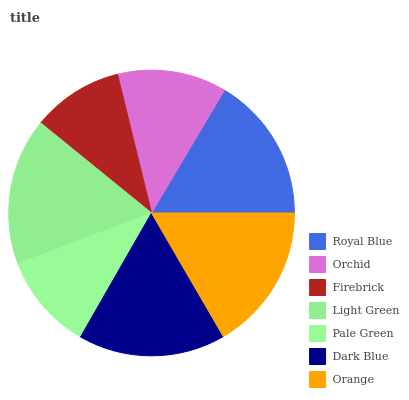Is Firebrick the minimum?
Answer yes or no. Yes. Is Dark Blue the maximum?
Answer yes or no. Yes. Is Orchid the minimum?
Answer yes or no. No. Is Orchid the maximum?
Answer yes or no. No. Is Royal Blue greater than Orchid?
Answer yes or no. Yes. Is Orchid less than Royal Blue?
Answer yes or no. Yes. Is Orchid greater than Royal Blue?
Answer yes or no. No. Is Royal Blue less than Orchid?
Answer yes or no. No. Is Royal Blue the high median?
Answer yes or no. Yes. Is Royal Blue the low median?
Answer yes or no. Yes. Is Pale Green the high median?
Answer yes or no. No. Is Light Green the low median?
Answer yes or no. No. 